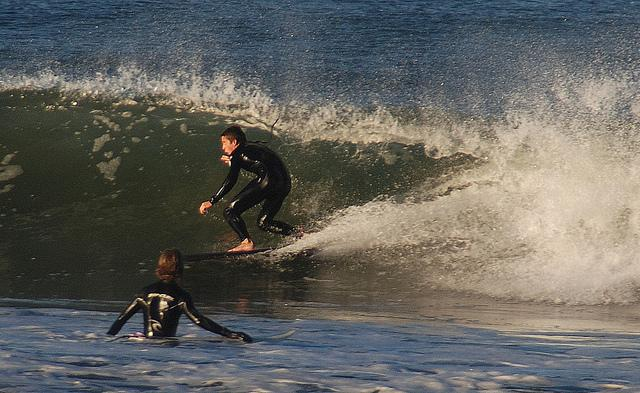Why is the man in black crouched? Please explain your reasoning. gain speed. Crouching lessens the wind resistance. 